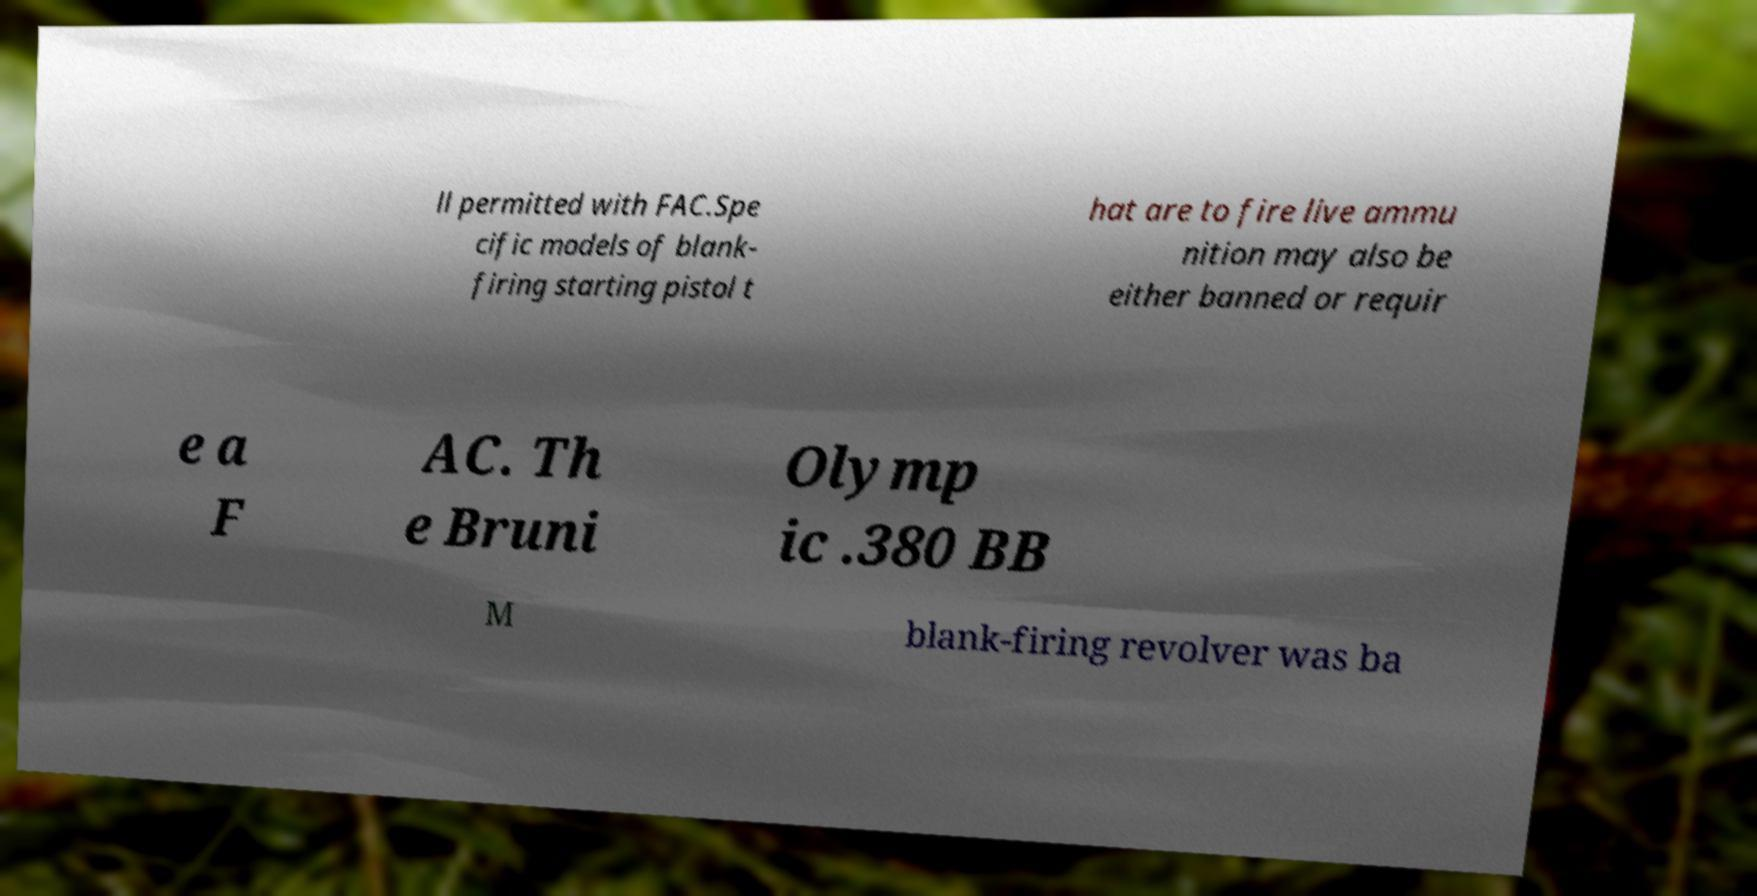Please identify and transcribe the text found in this image. ll permitted with FAC.Spe cific models of blank- firing starting pistol t hat are to fire live ammu nition may also be either banned or requir e a F AC. Th e Bruni Olymp ic .380 BB M blank-firing revolver was ba 